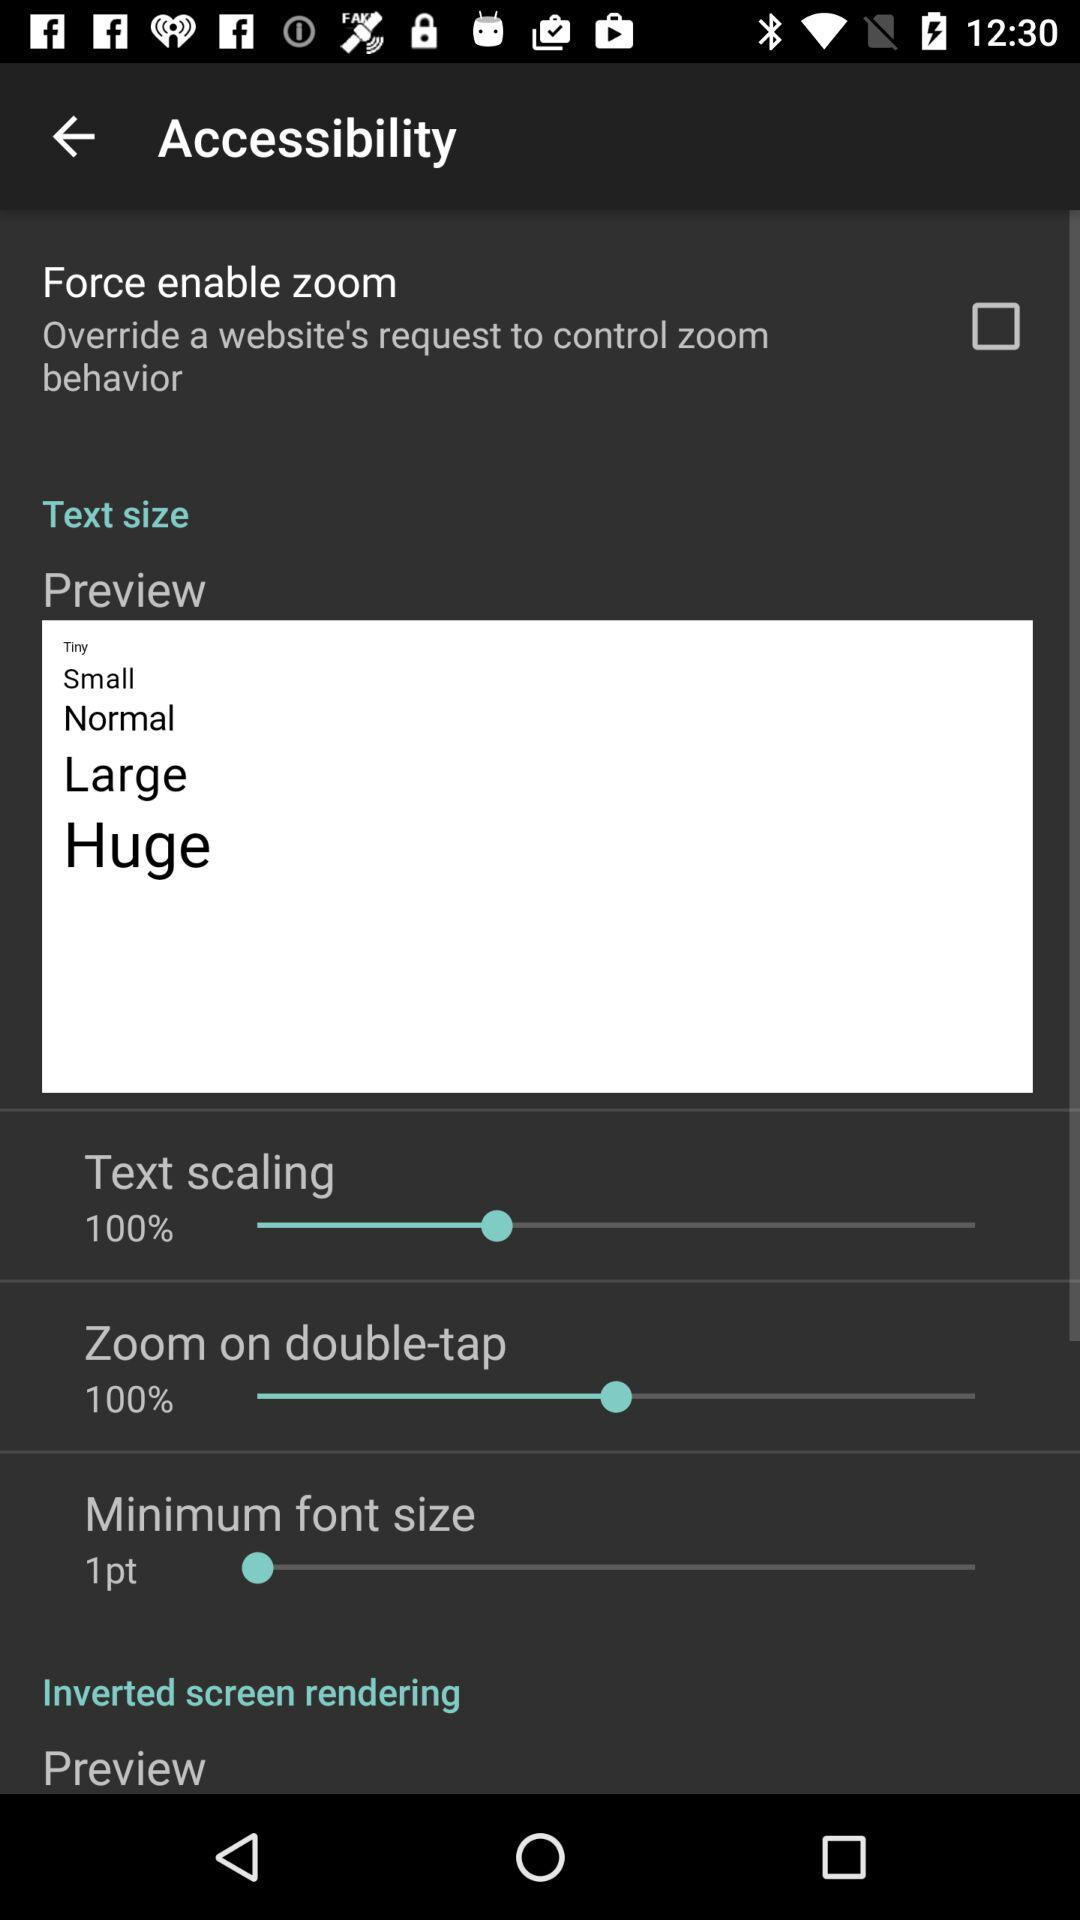How many text size options are there?
Answer the question using a single word or phrase. 4 